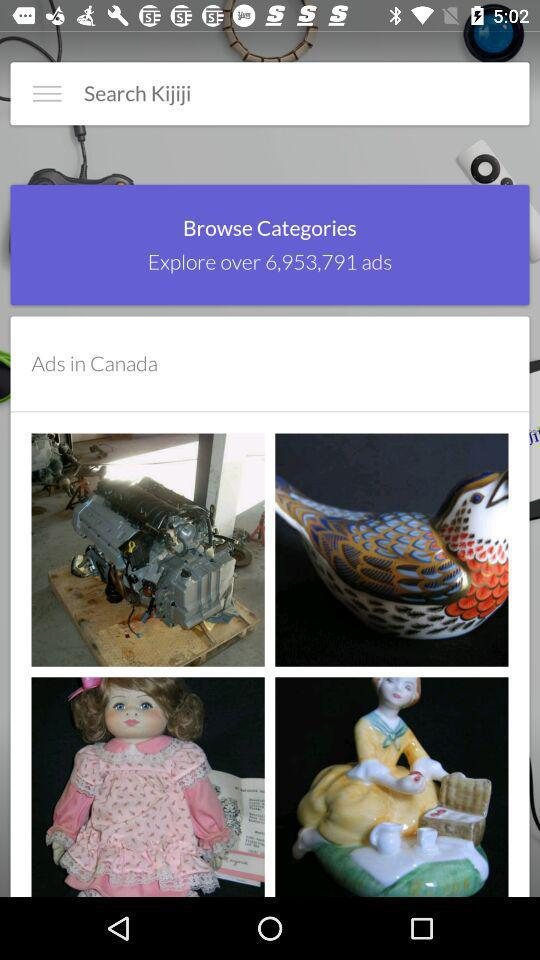What place are ads being displayed for? Ads are being displayed for Canada. 